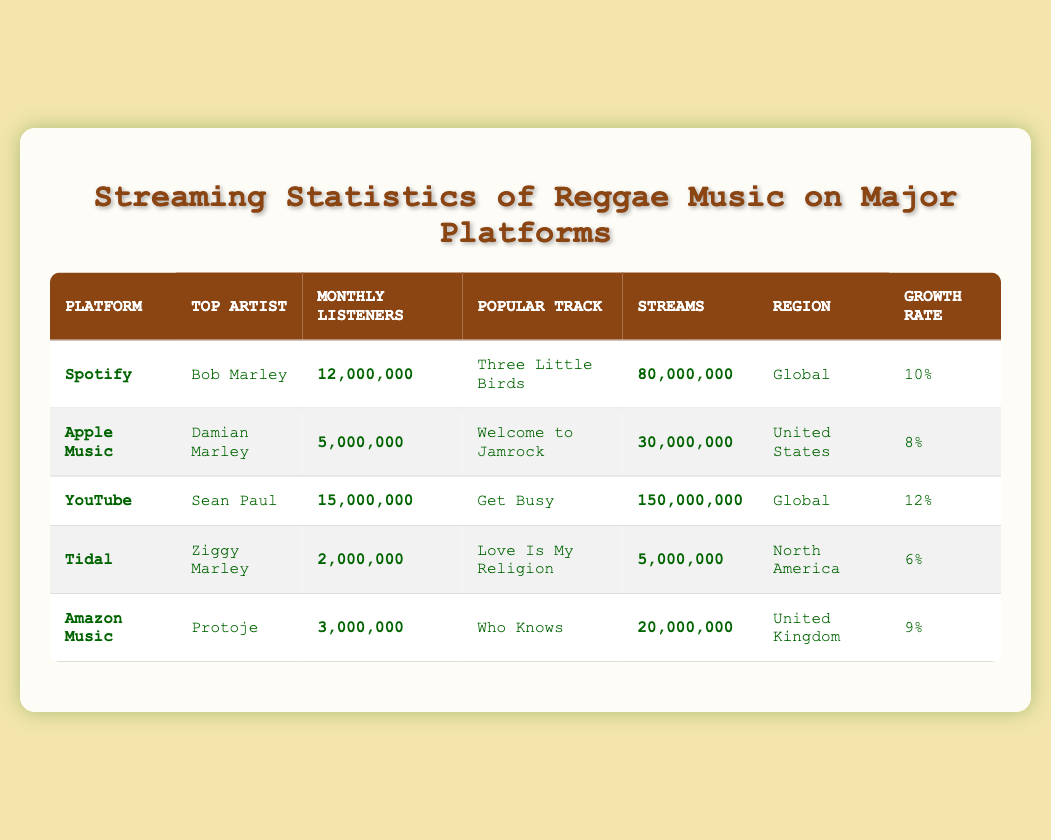What is the popular track on Spotify? The row for Spotify lists "Three Little Birds" under the Popular Track column.
Answer: Three Little Birds Who has the highest monthly listeners among the artists? The maximum monthly listeners can be found in the table under the Monthly Listeners column. Comparing the values, YouTube’s Sean Paul has 15,000,000 monthly listeners, which is the highest.
Answer: Sean Paul What percentage growth rate does Tidal have? In the Tidal row, the growth rate is listed as 6%.
Answer: 6% Which platform has the most streams? By comparing the Streams column, YouTube shows the highest value at 150,000,000 streams, more than any other platform.
Answer: YouTube What is the average monthly listeners across all platforms? The monthly listeners are: 12,000,000 (Spotify) + 5,000,000 (Apple Music) + 15,000,000 (YouTube) + 2,000,000 (Tidal) + 3,000,000 (Amazon Music). Summing these gives 37,000,000; dividing by 5 platforms gives an average of 7,400,000.
Answer: 7,400,000 Is Damian Marley the top artist on any platform? The table shows that Damian Marley is listed as the top artist under Apple Music, thus making him the top artist on that platform.
Answer: Yes How many more streams does Sean Paul have than Ziggy Marley? Sean Paul's streams total 150,000,000 compared to Ziggy Marley's 5,000,000. Subtracting these gives 150,000,000 - 5,000,000 = 145,000,000 streams more.
Answer: 145,000,000 Which platform has the lowest number of monthly listeners, and who is the top artist there? The Tidal row shows the lowest monthly listeners at 2,000,000, with Ziggy Marley as the top artist on that platform.
Answer: Tidal, Ziggy Marley Which region has the highest growth rate? The growth rates are: 10% (Spotify), 8% (Apple Music), 12% (YouTube), 6% (Tidal), 9% (Amazon Music). The highest is YouTube at 12%.
Answer: YouTube What is the total number of streams from platforms in North America? Only Tidal, with 5,000,000 streams, operates in North America. Therefore, the total from that region is 5,000,000.
Answer: 5,000,000 If you combined the monthly listeners for Spotify and YouTube, what would the total be? Spotify has 12,000,000 and YouTube has 15,000,000. Adding these together gives 12,000,000 + 15,000,000 = 27,000,000 total monthly listeners.
Answer: 27,000,000 